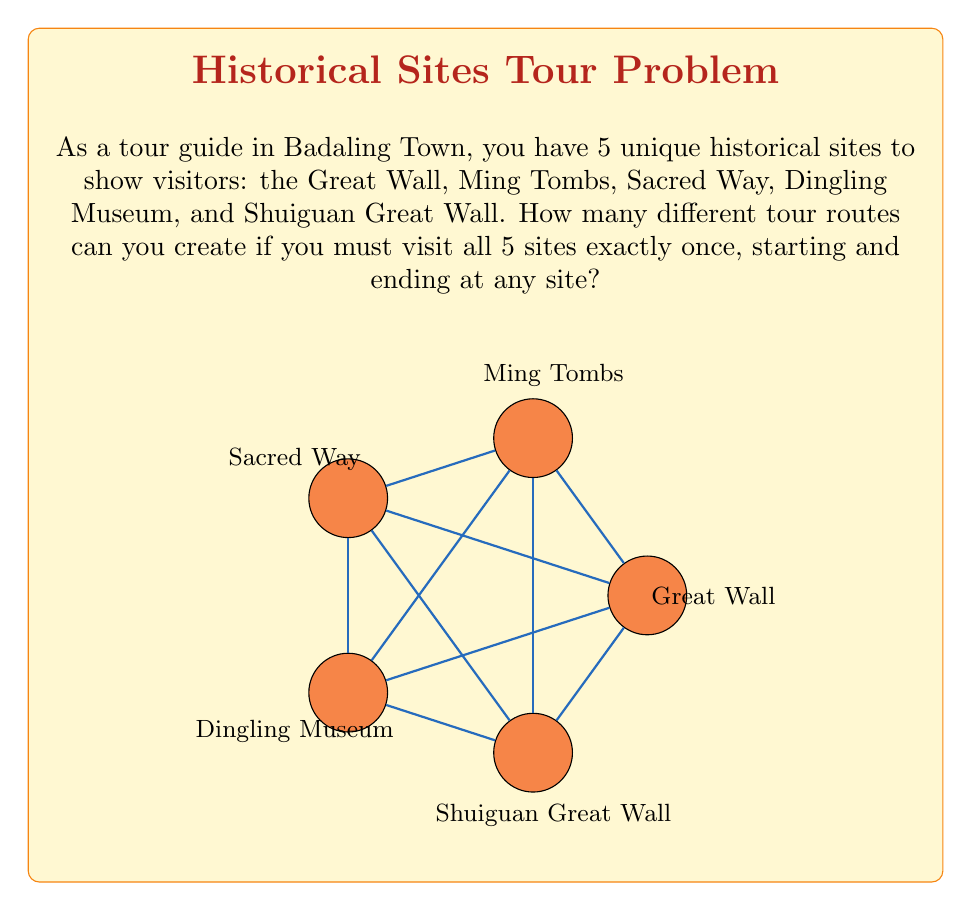Can you answer this question? To solve this problem, we can use the concept of cyclic permutations from abstract algebra.

1) First, let's consider why we use cyclic permutations:
   - We're creating a tour that visits all sites once and returns to the starting point.
   - This forms a cycle, where the starting point doesn't matter for uniqueness.

2) The number of unique cyclic permutations of $n$ distinct elements is $(n-1)!$.
   - This is because we can fix one element (say, the first) and permute the rest.

3) In our case, we have 5 sites, so $n = 5$.

4) Therefore, the number of unique tour routes is:
   $$(5-1)! = 4! = 4 \times 3 \times 2 \times 1 = 24$$

5) We can also understand this algebraically:
   - The total number of permutations of 5 elements is 5! = 120
   - But each unique cycle appears 5 times in this count (once starting from each element)
   - So we divide by 5 to get the number of unique cycles: $\frac{5!}{5} = 4! = 24$

This result means that as a tour guide, you can offer 24 distinct routes to showcase all 5 historical sites in Badaling Town.
Answer: 24 